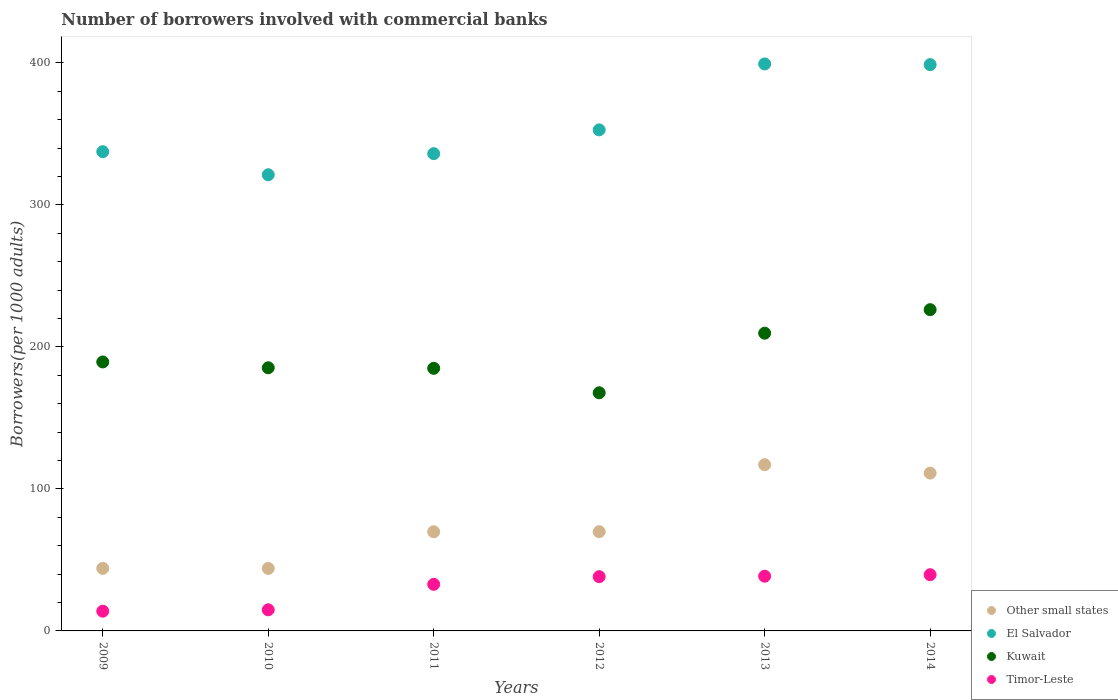How many different coloured dotlines are there?
Give a very brief answer. 4. What is the number of borrowers involved with commercial banks in Kuwait in 2009?
Ensure brevity in your answer.  189.42. Across all years, what is the maximum number of borrowers involved with commercial banks in Timor-Leste?
Make the answer very short. 39.6. Across all years, what is the minimum number of borrowers involved with commercial banks in Timor-Leste?
Offer a very short reply. 13.9. In which year was the number of borrowers involved with commercial banks in Timor-Leste maximum?
Offer a terse response. 2014. What is the total number of borrowers involved with commercial banks in Kuwait in the graph?
Your response must be concise. 1163.31. What is the difference between the number of borrowers involved with commercial banks in Kuwait in 2009 and that in 2011?
Your response must be concise. 4.47. What is the difference between the number of borrowers involved with commercial banks in Other small states in 2010 and the number of borrowers involved with commercial banks in Kuwait in 2009?
Offer a terse response. -145.41. What is the average number of borrowers involved with commercial banks in El Salvador per year?
Your answer should be compact. 357.65. In the year 2010, what is the difference between the number of borrowers involved with commercial banks in El Salvador and number of borrowers involved with commercial banks in Timor-Leste?
Your answer should be very brief. 306.4. What is the ratio of the number of borrowers involved with commercial banks in Other small states in 2011 to that in 2013?
Provide a short and direct response. 0.6. Is the number of borrowers involved with commercial banks in El Salvador in 2012 less than that in 2013?
Your response must be concise. Yes. Is the difference between the number of borrowers involved with commercial banks in El Salvador in 2009 and 2013 greater than the difference between the number of borrowers involved with commercial banks in Timor-Leste in 2009 and 2013?
Your answer should be very brief. No. What is the difference between the highest and the second highest number of borrowers involved with commercial banks in El Salvador?
Offer a very short reply. 0.49. What is the difference between the highest and the lowest number of borrowers involved with commercial banks in Kuwait?
Offer a terse response. 58.53. Is the sum of the number of borrowers involved with commercial banks in Timor-Leste in 2011 and 2014 greater than the maximum number of borrowers involved with commercial banks in Other small states across all years?
Your answer should be compact. No. Is it the case that in every year, the sum of the number of borrowers involved with commercial banks in Other small states and number of borrowers involved with commercial banks in El Salvador  is greater than the sum of number of borrowers involved with commercial banks in Kuwait and number of borrowers involved with commercial banks in Timor-Leste?
Offer a terse response. Yes. Is the number of borrowers involved with commercial banks in Other small states strictly greater than the number of borrowers involved with commercial banks in Kuwait over the years?
Give a very brief answer. No. How many dotlines are there?
Your answer should be very brief. 4. Are the values on the major ticks of Y-axis written in scientific E-notation?
Your answer should be compact. No. How are the legend labels stacked?
Provide a short and direct response. Vertical. What is the title of the graph?
Make the answer very short. Number of borrowers involved with commercial banks. What is the label or title of the Y-axis?
Ensure brevity in your answer.  Borrowers(per 1000 adults). What is the Borrowers(per 1000 adults) of Other small states in 2009?
Your answer should be very brief. 44.03. What is the Borrowers(per 1000 adults) of El Salvador in 2009?
Your response must be concise. 337.51. What is the Borrowers(per 1000 adults) of Kuwait in 2009?
Provide a short and direct response. 189.42. What is the Borrowers(per 1000 adults) of Timor-Leste in 2009?
Ensure brevity in your answer.  13.9. What is the Borrowers(per 1000 adults) in Other small states in 2010?
Provide a succinct answer. 44. What is the Borrowers(per 1000 adults) of El Salvador in 2010?
Ensure brevity in your answer.  321.27. What is the Borrowers(per 1000 adults) in Kuwait in 2010?
Offer a terse response. 185.32. What is the Borrowers(per 1000 adults) of Timor-Leste in 2010?
Offer a very short reply. 14.87. What is the Borrowers(per 1000 adults) in Other small states in 2011?
Offer a very short reply. 69.83. What is the Borrowers(per 1000 adults) in El Salvador in 2011?
Make the answer very short. 336.13. What is the Borrowers(per 1000 adults) in Kuwait in 2011?
Offer a very short reply. 184.94. What is the Borrowers(per 1000 adults) in Timor-Leste in 2011?
Provide a short and direct response. 32.81. What is the Borrowers(per 1000 adults) in Other small states in 2012?
Offer a very short reply. 69.88. What is the Borrowers(per 1000 adults) of El Salvador in 2012?
Ensure brevity in your answer.  352.87. What is the Borrowers(per 1000 adults) of Kuwait in 2012?
Your answer should be very brief. 167.71. What is the Borrowers(per 1000 adults) of Timor-Leste in 2012?
Provide a short and direct response. 38.21. What is the Borrowers(per 1000 adults) in Other small states in 2013?
Your response must be concise. 117.06. What is the Borrowers(per 1000 adults) of El Salvador in 2013?
Ensure brevity in your answer.  399.31. What is the Borrowers(per 1000 adults) in Kuwait in 2013?
Provide a succinct answer. 209.68. What is the Borrowers(per 1000 adults) of Timor-Leste in 2013?
Your answer should be compact. 38.53. What is the Borrowers(per 1000 adults) in Other small states in 2014?
Provide a short and direct response. 111.14. What is the Borrowers(per 1000 adults) of El Salvador in 2014?
Offer a very short reply. 398.82. What is the Borrowers(per 1000 adults) in Kuwait in 2014?
Provide a short and direct response. 226.24. What is the Borrowers(per 1000 adults) of Timor-Leste in 2014?
Make the answer very short. 39.6. Across all years, what is the maximum Borrowers(per 1000 adults) in Other small states?
Provide a succinct answer. 117.06. Across all years, what is the maximum Borrowers(per 1000 adults) of El Salvador?
Provide a succinct answer. 399.31. Across all years, what is the maximum Borrowers(per 1000 adults) of Kuwait?
Offer a terse response. 226.24. Across all years, what is the maximum Borrowers(per 1000 adults) of Timor-Leste?
Your answer should be very brief. 39.6. Across all years, what is the minimum Borrowers(per 1000 adults) of Other small states?
Provide a short and direct response. 44. Across all years, what is the minimum Borrowers(per 1000 adults) of El Salvador?
Your answer should be very brief. 321.27. Across all years, what is the minimum Borrowers(per 1000 adults) of Kuwait?
Your answer should be compact. 167.71. Across all years, what is the minimum Borrowers(per 1000 adults) of Timor-Leste?
Offer a very short reply. 13.9. What is the total Borrowers(per 1000 adults) of Other small states in the graph?
Ensure brevity in your answer.  455.95. What is the total Borrowers(per 1000 adults) in El Salvador in the graph?
Give a very brief answer. 2145.9. What is the total Borrowers(per 1000 adults) in Kuwait in the graph?
Your response must be concise. 1163.31. What is the total Borrowers(per 1000 adults) in Timor-Leste in the graph?
Make the answer very short. 177.93. What is the difference between the Borrowers(per 1000 adults) of Other small states in 2009 and that in 2010?
Offer a very short reply. 0.03. What is the difference between the Borrowers(per 1000 adults) in El Salvador in 2009 and that in 2010?
Give a very brief answer. 16.24. What is the difference between the Borrowers(per 1000 adults) of Kuwait in 2009 and that in 2010?
Keep it short and to the point. 4.09. What is the difference between the Borrowers(per 1000 adults) of Timor-Leste in 2009 and that in 2010?
Keep it short and to the point. -0.97. What is the difference between the Borrowers(per 1000 adults) of Other small states in 2009 and that in 2011?
Provide a short and direct response. -25.8. What is the difference between the Borrowers(per 1000 adults) in El Salvador in 2009 and that in 2011?
Provide a succinct answer. 1.39. What is the difference between the Borrowers(per 1000 adults) of Kuwait in 2009 and that in 2011?
Your answer should be very brief. 4.47. What is the difference between the Borrowers(per 1000 adults) in Timor-Leste in 2009 and that in 2011?
Ensure brevity in your answer.  -18.91. What is the difference between the Borrowers(per 1000 adults) of Other small states in 2009 and that in 2012?
Provide a succinct answer. -25.85. What is the difference between the Borrowers(per 1000 adults) of El Salvador in 2009 and that in 2012?
Keep it short and to the point. -15.36. What is the difference between the Borrowers(per 1000 adults) of Kuwait in 2009 and that in 2012?
Offer a very short reply. 21.7. What is the difference between the Borrowers(per 1000 adults) of Timor-Leste in 2009 and that in 2012?
Keep it short and to the point. -24.31. What is the difference between the Borrowers(per 1000 adults) of Other small states in 2009 and that in 2013?
Your response must be concise. -73.03. What is the difference between the Borrowers(per 1000 adults) in El Salvador in 2009 and that in 2013?
Offer a very short reply. -61.8. What is the difference between the Borrowers(per 1000 adults) in Kuwait in 2009 and that in 2013?
Offer a terse response. -20.26. What is the difference between the Borrowers(per 1000 adults) in Timor-Leste in 2009 and that in 2013?
Give a very brief answer. -24.63. What is the difference between the Borrowers(per 1000 adults) of Other small states in 2009 and that in 2014?
Make the answer very short. -67.11. What is the difference between the Borrowers(per 1000 adults) in El Salvador in 2009 and that in 2014?
Provide a short and direct response. -61.31. What is the difference between the Borrowers(per 1000 adults) of Kuwait in 2009 and that in 2014?
Keep it short and to the point. -36.83. What is the difference between the Borrowers(per 1000 adults) of Timor-Leste in 2009 and that in 2014?
Provide a succinct answer. -25.7. What is the difference between the Borrowers(per 1000 adults) of Other small states in 2010 and that in 2011?
Offer a very short reply. -25.83. What is the difference between the Borrowers(per 1000 adults) of El Salvador in 2010 and that in 2011?
Provide a short and direct response. -14.86. What is the difference between the Borrowers(per 1000 adults) in Kuwait in 2010 and that in 2011?
Keep it short and to the point. 0.38. What is the difference between the Borrowers(per 1000 adults) of Timor-Leste in 2010 and that in 2011?
Keep it short and to the point. -17.94. What is the difference between the Borrowers(per 1000 adults) in Other small states in 2010 and that in 2012?
Your answer should be very brief. -25.88. What is the difference between the Borrowers(per 1000 adults) of El Salvador in 2010 and that in 2012?
Your answer should be compact. -31.6. What is the difference between the Borrowers(per 1000 adults) of Kuwait in 2010 and that in 2012?
Keep it short and to the point. 17.61. What is the difference between the Borrowers(per 1000 adults) in Timor-Leste in 2010 and that in 2012?
Offer a very short reply. -23.34. What is the difference between the Borrowers(per 1000 adults) of Other small states in 2010 and that in 2013?
Offer a very short reply. -73.06. What is the difference between the Borrowers(per 1000 adults) of El Salvador in 2010 and that in 2013?
Give a very brief answer. -78.04. What is the difference between the Borrowers(per 1000 adults) in Kuwait in 2010 and that in 2013?
Keep it short and to the point. -24.35. What is the difference between the Borrowers(per 1000 adults) in Timor-Leste in 2010 and that in 2013?
Offer a very short reply. -23.66. What is the difference between the Borrowers(per 1000 adults) in Other small states in 2010 and that in 2014?
Provide a short and direct response. -67.14. What is the difference between the Borrowers(per 1000 adults) of El Salvador in 2010 and that in 2014?
Offer a terse response. -77.55. What is the difference between the Borrowers(per 1000 adults) of Kuwait in 2010 and that in 2014?
Your answer should be very brief. -40.92. What is the difference between the Borrowers(per 1000 adults) of Timor-Leste in 2010 and that in 2014?
Keep it short and to the point. -24.73. What is the difference between the Borrowers(per 1000 adults) in Other small states in 2011 and that in 2012?
Make the answer very short. -0.05. What is the difference between the Borrowers(per 1000 adults) in El Salvador in 2011 and that in 2012?
Your answer should be very brief. -16.75. What is the difference between the Borrowers(per 1000 adults) in Kuwait in 2011 and that in 2012?
Provide a succinct answer. 17.23. What is the difference between the Borrowers(per 1000 adults) in Timor-Leste in 2011 and that in 2012?
Your response must be concise. -5.4. What is the difference between the Borrowers(per 1000 adults) in Other small states in 2011 and that in 2013?
Your answer should be very brief. -47.23. What is the difference between the Borrowers(per 1000 adults) in El Salvador in 2011 and that in 2013?
Your answer should be compact. -63.18. What is the difference between the Borrowers(per 1000 adults) in Kuwait in 2011 and that in 2013?
Your answer should be very brief. -24.73. What is the difference between the Borrowers(per 1000 adults) in Timor-Leste in 2011 and that in 2013?
Offer a terse response. -5.72. What is the difference between the Borrowers(per 1000 adults) in Other small states in 2011 and that in 2014?
Ensure brevity in your answer.  -41.31. What is the difference between the Borrowers(per 1000 adults) of El Salvador in 2011 and that in 2014?
Provide a short and direct response. -62.69. What is the difference between the Borrowers(per 1000 adults) of Kuwait in 2011 and that in 2014?
Offer a terse response. -41.3. What is the difference between the Borrowers(per 1000 adults) of Timor-Leste in 2011 and that in 2014?
Give a very brief answer. -6.79. What is the difference between the Borrowers(per 1000 adults) of Other small states in 2012 and that in 2013?
Give a very brief answer. -47.18. What is the difference between the Borrowers(per 1000 adults) in El Salvador in 2012 and that in 2013?
Your response must be concise. -46.44. What is the difference between the Borrowers(per 1000 adults) of Kuwait in 2012 and that in 2013?
Provide a short and direct response. -41.96. What is the difference between the Borrowers(per 1000 adults) of Timor-Leste in 2012 and that in 2013?
Provide a short and direct response. -0.32. What is the difference between the Borrowers(per 1000 adults) of Other small states in 2012 and that in 2014?
Provide a short and direct response. -41.26. What is the difference between the Borrowers(per 1000 adults) of El Salvador in 2012 and that in 2014?
Provide a short and direct response. -45.95. What is the difference between the Borrowers(per 1000 adults) of Kuwait in 2012 and that in 2014?
Make the answer very short. -58.53. What is the difference between the Borrowers(per 1000 adults) in Timor-Leste in 2012 and that in 2014?
Your response must be concise. -1.39. What is the difference between the Borrowers(per 1000 adults) in Other small states in 2013 and that in 2014?
Ensure brevity in your answer.  5.92. What is the difference between the Borrowers(per 1000 adults) in El Salvador in 2013 and that in 2014?
Give a very brief answer. 0.49. What is the difference between the Borrowers(per 1000 adults) of Kuwait in 2013 and that in 2014?
Your answer should be very brief. -16.57. What is the difference between the Borrowers(per 1000 adults) in Timor-Leste in 2013 and that in 2014?
Your response must be concise. -1.07. What is the difference between the Borrowers(per 1000 adults) in Other small states in 2009 and the Borrowers(per 1000 adults) in El Salvador in 2010?
Your answer should be very brief. -277.24. What is the difference between the Borrowers(per 1000 adults) of Other small states in 2009 and the Borrowers(per 1000 adults) of Kuwait in 2010?
Ensure brevity in your answer.  -141.29. What is the difference between the Borrowers(per 1000 adults) in Other small states in 2009 and the Borrowers(per 1000 adults) in Timor-Leste in 2010?
Ensure brevity in your answer.  29.16. What is the difference between the Borrowers(per 1000 adults) of El Salvador in 2009 and the Borrowers(per 1000 adults) of Kuwait in 2010?
Offer a terse response. 152.19. What is the difference between the Borrowers(per 1000 adults) of El Salvador in 2009 and the Borrowers(per 1000 adults) of Timor-Leste in 2010?
Ensure brevity in your answer.  322.64. What is the difference between the Borrowers(per 1000 adults) of Kuwait in 2009 and the Borrowers(per 1000 adults) of Timor-Leste in 2010?
Your response must be concise. 174.55. What is the difference between the Borrowers(per 1000 adults) in Other small states in 2009 and the Borrowers(per 1000 adults) in El Salvador in 2011?
Offer a terse response. -292.1. What is the difference between the Borrowers(per 1000 adults) in Other small states in 2009 and the Borrowers(per 1000 adults) in Kuwait in 2011?
Your response must be concise. -140.91. What is the difference between the Borrowers(per 1000 adults) of Other small states in 2009 and the Borrowers(per 1000 adults) of Timor-Leste in 2011?
Your answer should be compact. 11.22. What is the difference between the Borrowers(per 1000 adults) of El Salvador in 2009 and the Borrowers(per 1000 adults) of Kuwait in 2011?
Keep it short and to the point. 152.57. What is the difference between the Borrowers(per 1000 adults) of El Salvador in 2009 and the Borrowers(per 1000 adults) of Timor-Leste in 2011?
Offer a terse response. 304.7. What is the difference between the Borrowers(per 1000 adults) of Kuwait in 2009 and the Borrowers(per 1000 adults) of Timor-Leste in 2011?
Your response must be concise. 156.61. What is the difference between the Borrowers(per 1000 adults) in Other small states in 2009 and the Borrowers(per 1000 adults) in El Salvador in 2012?
Ensure brevity in your answer.  -308.84. What is the difference between the Borrowers(per 1000 adults) of Other small states in 2009 and the Borrowers(per 1000 adults) of Kuwait in 2012?
Make the answer very short. -123.68. What is the difference between the Borrowers(per 1000 adults) in Other small states in 2009 and the Borrowers(per 1000 adults) in Timor-Leste in 2012?
Provide a short and direct response. 5.82. What is the difference between the Borrowers(per 1000 adults) in El Salvador in 2009 and the Borrowers(per 1000 adults) in Kuwait in 2012?
Give a very brief answer. 169.8. What is the difference between the Borrowers(per 1000 adults) in El Salvador in 2009 and the Borrowers(per 1000 adults) in Timor-Leste in 2012?
Offer a very short reply. 299.3. What is the difference between the Borrowers(per 1000 adults) of Kuwait in 2009 and the Borrowers(per 1000 adults) of Timor-Leste in 2012?
Provide a succinct answer. 151.21. What is the difference between the Borrowers(per 1000 adults) in Other small states in 2009 and the Borrowers(per 1000 adults) in El Salvador in 2013?
Your answer should be very brief. -355.28. What is the difference between the Borrowers(per 1000 adults) of Other small states in 2009 and the Borrowers(per 1000 adults) of Kuwait in 2013?
Offer a terse response. -165.65. What is the difference between the Borrowers(per 1000 adults) in Other small states in 2009 and the Borrowers(per 1000 adults) in Timor-Leste in 2013?
Ensure brevity in your answer.  5.5. What is the difference between the Borrowers(per 1000 adults) of El Salvador in 2009 and the Borrowers(per 1000 adults) of Kuwait in 2013?
Offer a terse response. 127.84. What is the difference between the Borrowers(per 1000 adults) in El Salvador in 2009 and the Borrowers(per 1000 adults) in Timor-Leste in 2013?
Make the answer very short. 298.98. What is the difference between the Borrowers(per 1000 adults) in Kuwait in 2009 and the Borrowers(per 1000 adults) in Timor-Leste in 2013?
Provide a short and direct response. 150.88. What is the difference between the Borrowers(per 1000 adults) of Other small states in 2009 and the Borrowers(per 1000 adults) of El Salvador in 2014?
Give a very brief answer. -354.79. What is the difference between the Borrowers(per 1000 adults) of Other small states in 2009 and the Borrowers(per 1000 adults) of Kuwait in 2014?
Provide a succinct answer. -182.21. What is the difference between the Borrowers(per 1000 adults) in Other small states in 2009 and the Borrowers(per 1000 adults) in Timor-Leste in 2014?
Provide a short and direct response. 4.43. What is the difference between the Borrowers(per 1000 adults) of El Salvador in 2009 and the Borrowers(per 1000 adults) of Kuwait in 2014?
Give a very brief answer. 111.27. What is the difference between the Borrowers(per 1000 adults) of El Salvador in 2009 and the Borrowers(per 1000 adults) of Timor-Leste in 2014?
Give a very brief answer. 297.91. What is the difference between the Borrowers(per 1000 adults) in Kuwait in 2009 and the Borrowers(per 1000 adults) in Timor-Leste in 2014?
Ensure brevity in your answer.  149.81. What is the difference between the Borrowers(per 1000 adults) of Other small states in 2010 and the Borrowers(per 1000 adults) of El Salvador in 2011?
Ensure brevity in your answer.  -292.12. What is the difference between the Borrowers(per 1000 adults) in Other small states in 2010 and the Borrowers(per 1000 adults) in Kuwait in 2011?
Offer a very short reply. -140.94. What is the difference between the Borrowers(per 1000 adults) in Other small states in 2010 and the Borrowers(per 1000 adults) in Timor-Leste in 2011?
Your response must be concise. 11.19. What is the difference between the Borrowers(per 1000 adults) in El Salvador in 2010 and the Borrowers(per 1000 adults) in Kuwait in 2011?
Give a very brief answer. 136.33. What is the difference between the Borrowers(per 1000 adults) of El Salvador in 2010 and the Borrowers(per 1000 adults) of Timor-Leste in 2011?
Ensure brevity in your answer.  288.46. What is the difference between the Borrowers(per 1000 adults) in Kuwait in 2010 and the Borrowers(per 1000 adults) in Timor-Leste in 2011?
Offer a terse response. 152.51. What is the difference between the Borrowers(per 1000 adults) in Other small states in 2010 and the Borrowers(per 1000 adults) in El Salvador in 2012?
Keep it short and to the point. -308.87. What is the difference between the Borrowers(per 1000 adults) in Other small states in 2010 and the Borrowers(per 1000 adults) in Kuwait in 2012?
Your answer should be compact. -123.71. What is the difference between the Borrowers(per 1000 adults) of Other small states in 2010 and the Borrowers(per 1000 adults) of Timor-Leste in 2012?
Your answer should be very brief. 5.8. What is the difference between the Borrowers(per 1000 adults) of El Salvador in 2010 and the Borrowers(per 1000 adults) of Kuwait in 2012?
Offer a terse response. 153.56. What is the difference between the Borrowers(per 1000 adults) of El Salvador in 2010 and the Borrowers(per 1000 adults) of Timor-Leste in 2012?
Make the answer very short. 283.06. What is the difference between the Borrowers(per 1000 adults) in Kuwait in 2010 and the Borrowers(per 1000 adults) in Timor-Leste in 2012?
Make the answer very short. 147.11. What is the difference between the Borrowers(per 1000 adults) in Other small states in 2010 and the Borrowers(per 1000 adults) in El Salvador in 2013?
Your response must be concise. -355.3. What is the difference between the Borrowers(per 1000 adults) of Other small states in 2010 and the Borrowers(per 1000 adults) of Kuwait in 2013?
Ensure brevity in your answer.  -165.67. What is the difference between the Borrowers(per 1000 adults) of Other small states in 2010 and the Borrowers(per 1000 adults) of Timor-Leste in 2013?
Offer a terse response. 5.47. What is the difference between the Borrowers(per 1000 adults) in El Salvador in 2010 and the Borrowers(per 1000 adults) in Kuwait in 2013?
Your response must be concise. 111.59. What is the difference between the Borrowers(per 1000 adults) of El Salvador in 2010 and the Borrowers(per 1000 adults) of Timor-Leste in 2013?
Your response must be concise. 282.73. What is the difference between the Borrowers(per 1000 adults) in Kuwait in 2010 and the Borrowers(per 1000 adults) in Timor-Leste in 2013?
Keep it short and to the point. 146.79. What is the difference between the Borrowers(per 1000 adults) of Other small states in 2010 and the Borrowers(per 1000 adults) of El Salvador in 2014?
Offer a terse response. -354.81. What is the difference between the Borrowers(per 1000 adults) in Other small states in 2010 and the Borrowers(per 1000 adults) in Kuwait in 2014?
Offer a terse response. -182.24. What is the difference between the Borrowers(per 1000 adults) in Other small states in 2010 and the Borrowers(per 1000 adults) in Timor-Leste in 2014?
Give a very brief answer. 4.4. What is the difference between the Borrowers(per 1000 adults) in El Salvador in 2010 and the Borrowers(per 1000 adults) in Kuwait in 2014?
Your answer should be compact. 95.03. What is the difference between the Borrowers(per 1000 adults) in El Salvador in 2010 and the Borrowers(per 1000 adults) in Timor-Leste in 2014?
Your answer should be compact. 281.67. What is the difference between the Borrowers(per 1000 adults) of Kuwait in 2010 and the Borrowers(per 1000 adults) of Timor-Leste in 2014?
Keep it short and to the point. 145.72. What is the difference between the Borrowers(per 1000 adults) in Other small states in 2011 and the Borrowers(per 1000 adults) in El Salvador in 2012?
Your answer should be compact. -283.04. What is the difference between the Borrowers(per 1000 adults) in Other small states in 2011 and the Borrowers(per 1000 adults) in Kuwait in 2012?
Your response must be concise. -97.88. What is the difference between the Borrowers(per 1000 adults) of Other small states in 2011 and the Borrowers(per 1000 adults) of Timor-Leste in 2012?
Your answer should be very brief. 31.62. What is the difference between the Borrowers(per 1000 adults) in El Salvador in 2011 and the Borrowers(per 1000 adults) in Kuwait in 2012?
Ensure brevity in your answer.  168.41. What is the difference between the Borrowers(per 1000 adults) of El Salvador in 2011 and the Borrowers(per 1000 adults) of Timor-Leste in 2012?
Make the answer very short. 297.92. What is the difference between the Borrowers(per 1000 adults) of Kuwait in 2011 and the Borrowers(per 1000 adults) of Timor-Leste in 2012?
Give a very brief answer. 146.73. What is the difference between the Borrowers(per 1000 adults) of Other small states in 2011 and the Borrowers(per 1000 adults) of El Salvador in 2013?
Give a very brief answer. -329.47. What is the difference between the Borrowers(per 1000 adults) in Other small states in 2011 and the Borrowers(per 1000 adults) in Kuwait in 2013?
Provide a succinct answer. -139.84. What is the difference between the Borrowers(per 1000 adults) in Other small states in 2011 and the Borrowers(per 1000 adults) in Timor-Leste in 2013?
Keep it short and to the point. 31.3. What is the difference between the Borrowers(per 1000 adults) of El Salvador in 2011 and the Borrowers(per 1000 adults) of Kuwait in 2013?
Make the answer very short. 126.45. What is the difference between the Borrowers(per 1000 adults) in El Salvador in 2011 and the Borrowers(per 1000 adults) in Timor-Leste in 2013?
Offer a very short reply. 297.59. What is the difference between the Borrowers(per 1000 adults) in Kuwait in 2011 and the Borrowers(per 1000 adults) in Timor-Leste in 2013?
Offer a terse response. 146.41. What is the difference between the Borrowers(per 1000 adults) in Other small states in 2011 and the Borrowers(per 1000 adults) in El Salvador in 2014?
Your response must be concise. -328.99. What is the difference between the Borrowers(per 1000 adults) in Other small states in 2011 and the Borrowers(per 1000 adults) in Kuwait in 2014?
Your answer should be very brief. -156.41. What is the difference between the Borrowers(per 1000 adults) of Other small states in 2011 and the Borrowers(per 1000 adults) of Timor-Leste in 2014?
Your response must be concise. 30.23. What is the difference between the Borrowers(per 1000 adults) of El Salvador in 2011 and the Borrowers(per 1000 adults) of Kuwait in 2014?
Your response must be concise. 109.88. What is the difference between the Borrowers(per 1000 adults) in El Salvador in 2011 and the Borrowers(per 1000 adults) in Timor-Leste in 2014?
Your answer should be compact. 296.52. What is the difference between the Borrowers(per 1000 adults) of Kuwait in 2011 and the Borrowers(per 1000 adults) of Timor-Leste in 2014?
Your answer should be very brief. 145.34. What is the difference between the Borrowers(per 1000 adults) of Other small states in 2012 and the Borrowers(per 1000 adults) of El Salvador in 2013?
Your answer should be very brief. -329.43. What is the difference between the Borrowers(per 1000 adults) of Other small states in 2012 and the Borrowers(per 1000 adults) of Kuwait in 2013?
Offer a terse response. -139.79. What is the difference between the Borrowers(per 1000 adults) in Other small states in 2012 and the Borrowers(per 1000 adults) in Timor-Leste in 2013?
Your answer should be very brief. 31.35. What is the difference between the Borrowers(per 1000 adults) in El Salvador in 2012 and the Borrowers(per 1000 adults) in Kuwait in 2013?
Your response must be concise. 143.2. What is the difference between the Borrowers(per 1000 adults) in El Salvador in 2012 and the Borrowers(per 1000 adults) in Timor-Leste in 2013?
Provide a succinct answer. 314.34. What is the difference between the Borrowers(per 1000 adults) of Kuwait in 2012 and the Borrowers(per 1000 adults) of Timor-Leste in 2013?
Give a very brief answer. 129.18. What is the difference between the Borrowers(per 1000 adults) in Other small states in 2012 and the Borrowers(per 1000 adults) in El Salvador in 2014?
Ensure brevity in your answer.  -328.94. What is the difference between the Borrowers(per 1000 adults) in Other small states in 2012 and the Borrowers(per 1000 adults) in Kuwait in 2014?
Your response must be concise. -156.36. What is the difference between the Borrowers(per 1000 adults) in Other small states in 2012 and the Borrowers(per 1000 adults) in Timor-Leste in 2014?
Ensure brevity in your answer.  30.28. What is the difference between the Borrowers(per 1000 adults) of El Salvador in 2012 and the Borrowers(per 1000 adults) of Kuwait in 2014?
Make the answer very short. 126.63. What is the difference between the Borrowers(per 1000 adults) of El Salvador in 2012 and the Borrowers(per 1000 adults) of Timor-Leste in 2014?
Ensure brevity in your answer.  313.27. What is the difference between the Borrowers(per 1000 adults) in Kuwait in 2012 and the Borrowers(per 1000 adults) in Timor-Leste in 2014?
Give a very brief answer. 128.11. What is the difference between the Borrowers(per 1000 adults) of Other small states in 2013 and the Borrowers(per 1000 adults) of El Salvador in 2014?
Make the answer very short. -281.76. What is the difference between the Borrowers(per 1000 adults) of Other small states in 2013 and the Borrowers(per 1000 adults) of Kuwait in 2014?
Your answer should be very brief. -109.18. What is the difference between the Borrowers(per 1000 adults) in Other small states in 2013 and the Borrowers(per 1000 adults) in Timor-Leste in 2014?
Provide a succinct answer. 77.46. What is the difference between the Borrowers(per 1000 adults) of El Salvador in 2013 and the Borrowers(per 1000 adults) of Kuwait in 2014?
Provide a succinct answer. 173.07. What is the difference between the Borrowers(per 1000 adults) in El Salvador in 2013 and the Borrowers(per 1000 adults) in Timor-Leste in 2014?
Keep it short and to the point. 359.7. What is the difference between the Borrowers(per 1000 adults) in Kuwait in 2013 and the Borrowers(per 1000 adults) in Timor-Leste in 2014?
Make the answer very short. 170.07. What is the average Borrowers(per 1000 adults) in Other small states per year?
Ensure brevity in your answer.  75.99. What is the average Borrowers(per 1000 adults) in El Salvador per year?
Keep it short and to the point. 357.65. What is the average Borrowers(per 1000 adults) of Kuwait per year?
Your answer should be compact. 193.88. What is the average Borrowers(per 1000 adults) in Timor-Leste per year?
Ensure brevity in your answer.  29.65. In the year 2009, what is the difference between the Borrowers(per 1000 adults) of Other small states and Borrowers(per 1000 adults) of El Salvador?
Offer a very short reply. -293.48. In the year 2009, what is the difference between the Borrowers(per 1000 adults) in Other small states and Borrowers(per 1000 adults) in Kuwait?
Provide a succinct answer. -145.39. In the year 2009, what is the difference between the Borrowers(per 1000 adults) in Other small states and Borrowers(per 1000 adults) in Timor-Leste?
Your answer should be compact. 30.13. In the year 2009, what is the difference between the Borrowers(per 1000 adults) of El Salvador and Borrowers(per 1000 adults) of Kuwait?
Provide a succinct answer. 148.1. In the year 2009, what is the difference between the Borrowers(per 1000 adults) in El Salvador and Borrowers(per 1000 adults) in Timor-Leste?
Keep it short and to the point. 323.61. In the year 2009, what is the difference between the Borrowers(per 1000 adults) in Kuwait and Borrowers(per 1000 adults) in Timor-Leste?
Provide a succinct answer. 175.51. In the year 2010, what is the difference between the Borrowers(per 1000 adults) in Other small states and Borrowers(per 1000 adults) in El Salvador?
Your answer should be very brief. -277.26. In the year 2010, what is the difference between the Borrowers(per 1000 adults) in Other small states and Borrowers(per 1000 adults) in Kuwait?
Ensure brevity in your answer.  -141.32. In the year 2010, what is the difference between the Borrowers(per 1000 adults) of Other small states and Borrowers(per 1000 adults) of Timor-Leste?
Offer a terse response. 29.13. In the year 2010, what is the difference between the Borrowers(per 1000 adults) of El Salvador and Borrowers(per 1000 adults) of Kuwait?
Make the answer very short. 135.95. In the year 2010, what is the difference between the Borrowers(per 1000 adults) of El Salvador and Borrowers(per 1000 adults) of Timor-Leste?
Offer a very short reply. 306.4. In the year 2010, what is the difference between the Borrowers(per 1000 adults) of Kuwait and Borrowers(per 1000 adults) of Timor-Leste?
Provide a succinct answer. 170.45. In the year 2011, what is the difference between the Borrowers(per 1000 adults) in Other small states and Borrowers(per 1000 adults) in El Salvador?
Ensure brevity in your answer.  -266.29. In the year 2011, what is the difference between the Borrowers(per 1000 adults) of Other small states and Borrowers(per 1000 adults) of Kuwait?
Offer a terse response. -115.11. In the year 2011, what is the difference between the Borrowers(per 1000 adults) of Other small states and Borrowers(per 1000 adults) of Timor-Leste?
Your response must be concise. 37.02. In the year 2011, what is the difference between the Borrowers(per 1000 adults) of El Salvador and Borrowers(per 1000 adults) of Kuwait?
Your answer should be compact. 151.18. In the year 2011, what is the difference between the Borrowers(per 1000 adults) in El Salvador and Borrowers(per 1000 adults) in Timor-Leste?
Provide a succinct answer. 303.32. In the year 2011, what is the difference between the Borrowers(per 1000 adults) of Kuwait and Borrowers(per 1000 adults) of Timor-Leste?
Keep it short and to the point. 152.13. In the year 2012, what is the difference between the Borrowers(per 1000 adults) of Other small states and Borrowers(per 1000 adults) of El Salvador?
Ensure brevity in your answer.  -282.99. In the year 2012, what is the difference between the Borrowers(per 1000 adults) in Other small states and Borrowers(per 1000 adults) in Kuwait?
Provide a short and direct response. -97.83. In the year 2012, what is the difference between the Borrowers(per 1000 adults) of Other small states and Borrowers(per 1000 adults) of Timor-Leste?
Your answer should be compact. 31.67. In the year 2012, what is the difference between the Borrowers(per 1000 adults) in El Salvador and Borrowers(per 1000 adults) in Kuwait?
Ensure brevity in your answer.  185.16. In the year 2012, what is the difference between the Borrowers(per 1000 adults) of El Salvador and Borrowers(per 1000 adults) of Timor-Leste?
Give a very brief answer. 314.66. In the year 2012, what is the difference between the Borrowers(per 1000 adults) in Kuwait and Borrowers(per 1000 adults) in Timor-Leste?
Your response must be concise. 129.5. In the year 2013, what is the difference between the Borrowers(per 1000 adults) of Other small states and Borrowers(per 1000 adults) of El Salvador?
Give a very brief answer. -282.25. In the year 2013, what is the difference between the Borrowers(per 1000 adults) in Other small states and Borrowers(per 1000 adults) in Kuwait?
Offer a very short reply. -92.62. In the year 2013, what is the difference between the Borrowers(per 1000 adults) in Other small states and Borrowers(per 1000 adults) in Timor-Leste?
Ensure brevity in your answer.  78.53. In the year 2013, what is the difference between the Borrowers(per 1000 adults) of El Salvador and Borrowers(per 1000 adults) of Kuwait?
Your answer should be compact. 189.63. In the year 2013, what is the difference between the Borrowers(per 1000 adults) in El Salvador and Borrowers(per 1000 adults) in Timor-Leste?
Make the answer very short. 360.77. In the year 2013, what is the difference between the Borrowers(per 1000 adults) of Kuwait and Borrowers(per 1000 adults) of Timor-Leste?
Give a very brief answer. 171.14. In the year 2014, what is the difference between the Borrowers(per 1000 adults) of Other small states and Borrowers(per 1000 adults) of El Salvador?
Offer a terse response. -287.68. In the year 2014, what is the difference between the Borrowers(per 1000 adults) in Other small states and Borrowers(per 1000 adults) in Kuwait?
Your answer should be compact. -115.1. In the year 2014, what is the difference between the Borrowers(per 1000 adults) of Other small states and Borrowers(per 1000 adults) of Timor-Leste?
Your response must be concise. 71.54. In the year 2014, what is the difference between the Borrowers(per 1000 adults) of El Salvador and Borrowers(per 1000 adults) of Kuwait?
Offer a very short reply. 172.58. In the year 2014, what is the difference between the Borrowers(per 1000 adults) of El Salvador and Borrowers(per 1000 adults) of Timor-Leste?
Your response must be concise. 359.22. In the year 2014, what is the difference between the Borrowers(per 1000 adults) in Kuwait and Borrowers(per 1000 adults) in Timor-Leste?
Give a very brief answer. 186.64. What is the ratio of the Borrowers(per 1000 adults) in El Salvador in 2009 to that in 2010?
Keep it short and to the point. 1.05. What is the ratio of the Borrowers(per 1000 adults) of Kuwait in 2009 to that in 2010?
Offer a terse response. 1.02. What is the ratio of the Borrowers(per 1000 adults) in Timor-Leste in 2009 to that in 2010?
Your answer should be very brief. 0.94. What is the ratio of the Borrowers(per 1000 adults) in Other small states in 2009 to that in 2011?
Your answer should be very brief. 0.63. What is the ratio of the Borrowers(per 1000 adults) of El Salvador in 2009 to that in 2011?
Your answer should be very brief. 1. What is the ratio of the Borrowers(per 1000 adults) of Kuwait in 2009 to that in 2011?
Offer a terse response. 1.02. What is the ratio of the Borrowers(per 1000 adults) in Timor-Leste in 2009 to that in 2011?
Give a very brief answer. 0.42. What is the ratio of the Borrowers(per 1000 adults) in Other small states in 2009 to that in 2012?
Ensure brevity in your answer.  0.63. What is the ratio of the Borrowers(per 1000 adults) of El Salvador in 2009 to that in 2012?
Ensure brevity in your answer.  0.96. What is the ratio of the Borrowers(per 1000 adults) of Kuwait in 2009 to that in 2012?
Offer a very short reply. 1.13. What is the ratio of the Borrowers(per 1000 adults) in Timor-Leste in 2009 to that in 2012?
Your response must be concise. 0.36. What is the ratio of the Borrowers(per 1000 adults) of Other small states in 2009 to that in 2013?
Your answer should be compact. 0.38. What is the ratio of the Borrowers(per 1000 adults) in El Salvador in 2009 to that in 2013?
Make the answer very short. 0.85. What is the ratio of the Borrowers(per 1000 adults) of Kuwait in 2009 to that in 2013?
Your response must be concise. 0.9. What is the ratio of the Borrowers(per 1000 adults) of Timor-Leste in 2009 to that in 2013?
Provide a short and direct response. 0.36. What is the ratio of the Borrowers(per 1000 adults) of Other small states in 2009 to that in 2014?
Your answer should be very brief. 0.4. What is the ratio of the Borrowers(per 1000 adults) in El Salvador in 2009 to that in 2014?
Your answer should be very brief. 0.85. What is the ratio of the Borrowers(per 1000 adults) in Kuwait in 2009 to that in 2014?
Offer a terse response. 0.84. What is the ratio of the Borrowers(per 1000 adults) of Timor-Leste in 2009 to that in 2014?
Give a very brief answer. 0.35. What is the ratio of the Borrowers(per 1000 adults) in Other small states in 2010 to that in 2011?
Keep it short and to the point. 0.63. What is the ratio of the Borrowers(per 1000 adults) of El Salvador in 2010 to that in 2011?
Make the answer very short. 0.96. What is the ratio of the Borrowers(per 1000 adults) in Timor-Leste in 2010 to that in 2011?
Provide a succinct answer. 0.45. What is the ratio of the Borrowers(per 1000 adults) in Other small states in 2010 to that in 2012?
Provide a short and direct response. 0.63. What is the ratio of the Borrowers(per 1000 adults) of El Salvador in 2010 to that in 2012?
Your answer should be very brief. 0.91. What is the ratio of the Borrowers(per 1000 adults) in Kuwait in 2010 to that in 2012?
Make the answer very short. 1.1. What is the ratio of the Borrowers(per 1000 adults) of Timor-Leste in 2010 to that in 2012?
Your answer should be compact. 0.39. What is the ratio of the Borrowers(per 1000 adults) in Other small states in 2010 to that in 2013?
Offer a very short reply. 0.38. What is the ratio of the Borrowers(per 1000 adults) of El Salvador in 2010 to that in 2013?
Offer a terse response. 0.8. What is the ratio of the Borrowers(per 1000 adults) of Kuwait in 2010 to that in 2013?
Keep it short and to the point. 0.88. What is the ratio of the Borrowers(per 1000 adults) of Timor-Leste in 2010 to that in 2013?
Offer a very short reply. 0.39. What is the ratio of the Borrowers(per 1000 adults) of Other small states in 2010 to that in 2014?
Make the answer very short. 0.4. What is the ratio of the Borrowers(per 1000 adults) of El Salvador in 2010 to that in 2014?
Your answer should be very brief. 0.81. What is the ratio of the Borrowers(per 1000 adults) of Kuwait in 2010 to that in 2014?
Offer a terse response. 0.82. What is the ratio of the Borrowers(per 1000 adults) of Timor-Leste in 2010 to that in 2014?
Give a very brief answer. 0.38. What is the ratio of the Borrowers(per 1000 adults) of Other small states in 2011 to that in 2012?
Keep it short and to the point. 1. What is the ratio of the Borrowers(per 1000 adults) of El Salvador in 2011 to that in 2012?
Give a very brief answer. 0.95. What is the ratio of the Borrowers(per 1000 adults) of Kuwait in 2011 to that in 2012?
Your response must be concise. 1.1. What is the ratio of the Borrowers(per 1000 adults) of Timor-Leste in 2011 to that in 2012?
Offer a terse response. 0.86. What is the ratio of the Borrowers(per 1000 adults) in Other small states in 2011 to that in 2013?
Offer a terse response. 0.6. What is the ratio of the Borrowers(per 1000 adults) of El Salvador in 2011 to that in 2013?
Keep it short and to the point. 0.84. What is the ratio of the Borrowers(per 1000 adults) of Kuwait in 2011 to that in 2013?
Provide a short and direct response. 0.88. What is the ratio of the Borrowers(per 1000 adults) of Timor-Leste in 2011 to that in 2013?
Give a very brief answer. 0.85. What is the ratio of the Borrowers(per 1000 adults) of Other small states in 2011 to that in 2014?
Offer a very short reply. 0.63. What is the ratio of the Borrowers(per 1000 adults) of El Salvador in 2011 to that in 2014?
Your answer should be compact. 0.84. What is the ratio of the Borrowers(per 1000 adults) in Kuwait in 2011 to that in 2014?
Ensure brevity in your answer.  0.82. What is the ratio of the Borrowers(per 1000 adults) of Timor-Leste in 2011 to that in 2014?
Keep it short and to the point. 0.83. What is the ratio of the Borrowers(per 1000 adults) of Other small states in 2012 to that in 2013?
Provide a succinct answer. 0.6. What is the ratio of the Borrowers(per 1000 adults) in El Salvador in 2012 to that in 2013?
Your response must be concise. 0.88. What is the ratio of the Borrowers(per 1000 adults) in Kuwait in 2012 to that in 2013?
Give a very brief answer. 0.8. What is the ratio of the Borrowers(per 1000 adults) of Other small states in 2012 to that in 2014?
Ensure brevity in your answer.  0.63. What is the ratio of the Borrowers(per 1000 adults) of El Salvador in 2012 to that in 2014?
Your answer should be very brief. 0.88. What is the ratio of the Borrowers(per 1000 adults) in Kuwait in 2012 to that in 2014?
Ensure brevity in your answer.  0.74. What is the ratio of the Borrowers(per 1000 adults) of Timor-Leste in 2012 to that in 2014?
Offer a terse response. 0.96. What is the ratio of the Borrowers(per 1000 adults) in Other small states in 2013 to that in 2014?
Give a very brief answer. 1.05. What is the ratio of the Borrowers(per 1000 adults) of El Salvador in 2013 to that in 2014?
Your answer should be very brief. 1. What is the ratio of the Borrowers(per 1000 adults) of Kuwait in 2013 to that in 2014?
Offer a very short reply. 0.93. What is the ratio of the Borrowers(per 1000 adults) of Timor-Leste in 2013 to that in 2014?
Provide a short and direct response. 0.97. What is the difference between the highest and the second highest Borrowers(per 1000 adults) in Other small states?
Offer a very short reply. 5.92. What is the difference between the highest and the second highest Borrowers(per 1000 adults) of El Salvador?
Give a very brief answer. 0.49. What is the difference between the highest and the second highest Borrowers(per 1000 adults) in Kuwait?
Your answer should be very brief. 16.57. What is the difference between the highest and the second highest Borrowers(per 1000 adults) in Timor-Leste?
Your response must be concise. 1.07. What is the difference between the highest and the lowest Borrowers(per 1000 adults) of Other small states?
Your answer should be very brief. 73.06. What is the difference between the highest and the lowest Borrowers(per 1000 adults) in El Salvador?
Your response must be concise. 78.04. What is the difference between the highest and the lowest Borrowers(per 1000 adults) of Kuwait?
Your answer should be very brief. 58.53. What is the difference between the highest and the lowest Borrowers(per 1000 adults) of Timor-Leste?
Make the answer very short. 25.7. 